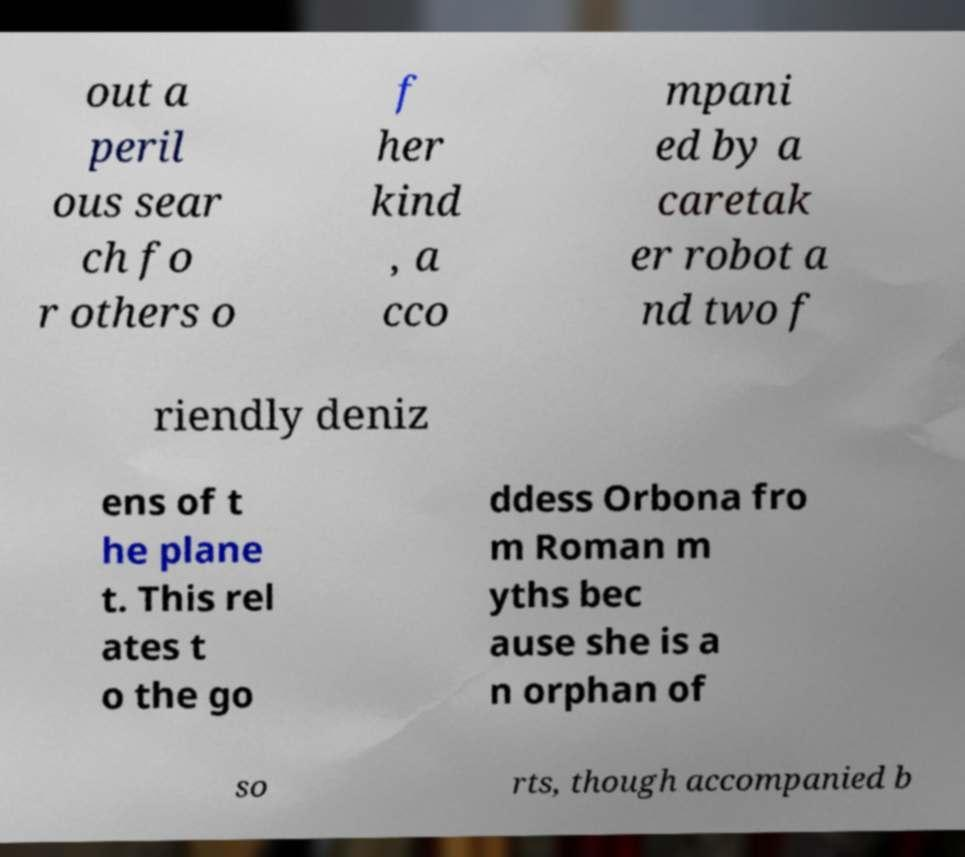Can you accurately transcribe the text from the provided image for me? out a peril ous sear ch fo r others o f her kind , a cco mpani ed by a caretak er robot a nd two f riendly deniz ens of t he plane t. This rel ates t o the go ddess Orbona fro m Roman m yths bec ause she is a n orphan of so rts, though accompanied b 